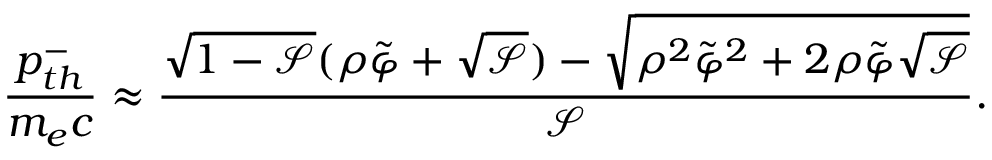<formula> <loc_0><loc_0><loc_500><loc_500>\frac { p _ { t h } ^ { - } } { m _ { e } c } \approx \frac { \sqrt { 1 - \mathcal { S } } ( \rho \tilde { \varphi } + \sqrt { \mathcal { S } } ) - \sqrt { \rho ^ { 2 } \tilde { \varphi } ^ { 2 } + 2 \rho \tilde { \varphi } \sqrt { \mathcal { S } } } } { \mathcal { S } } .</formula> 